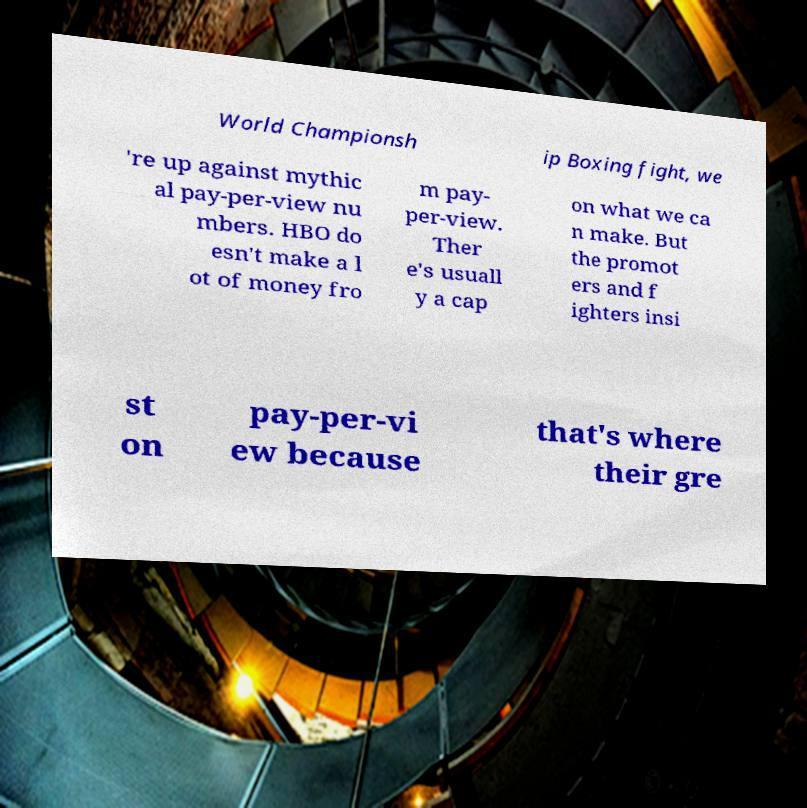Could you extract and type out the text from this image? World Championsh ip Boxing fight, we 're up against mythic al pay-per-view nu mbers. HBO do esn't make a l ot of money fro m pay- per-view. Ther e's usuall y a cap on what we ca n make. But the promot ers and f ighters insi st on pay-per-vi ew because that's where their gre 